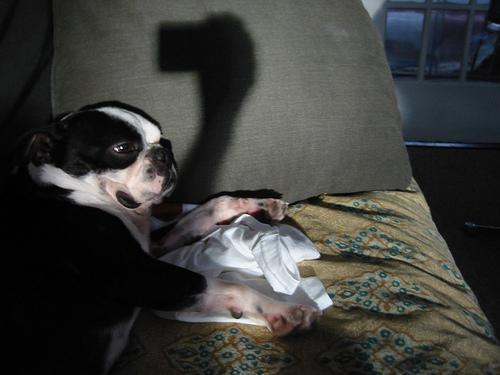How many black skateboards are in the image?
Give a very brief answer. 0. 